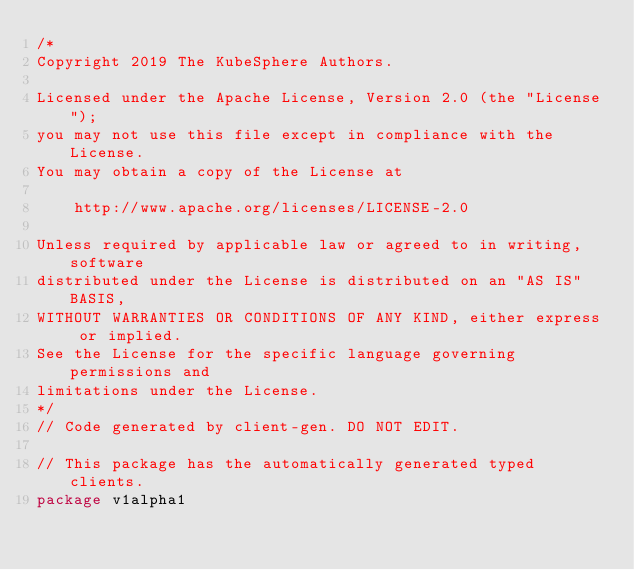Convert code to text. <code><loc_0><loc_0><loc_500><loc_500><_Go_>/*
Copyright 2019 The KubeSphere Authors.

Licensed under the Apache License, Version 2.0 (the "License");
you may not use this file except in compliance with the License.
You may obtain a copy of the License at

    http://www.apache.org/licenses/LICENSE-2.0

Unless required by applicable law or agreed to in writing, software
distributed under the License is distributed on an "AS IS" BASIS,
WITHOUT WARRANTIES OR CONDITIONS OF ANY KIND, either express or implied.
See the License for the specific language governing permissions and
limitations under the License.
*/
// Code generated by client-gen. DO NOT EDIT.

// This package has the automatically generated typed clients.
package v1alpha1
</code> 